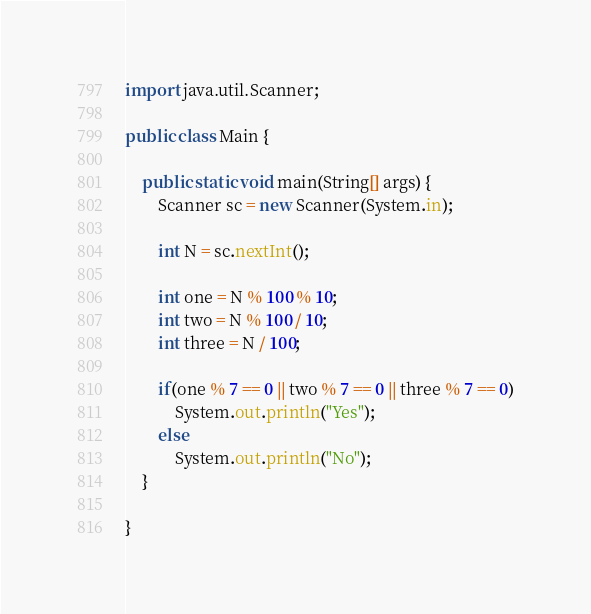<code> <loc_0><loc_0><loc_500><loc_500><_Java_>import java.util.Scanner;

public class Main {

	public static void main(String[] args) {
		Scanner sc = new Scanner(System.in);

		int N = sc.nextInt();

		int one = N % 100 % 10;
		int two = N % 100 / 10;
		int three = N / 100;
		
		if(one % 7 == 0 || two % 7 == 0 || three % 7 == 0)
			System.out.println("Yes");
		else
			System.out.println("No");
	}

}</code> 